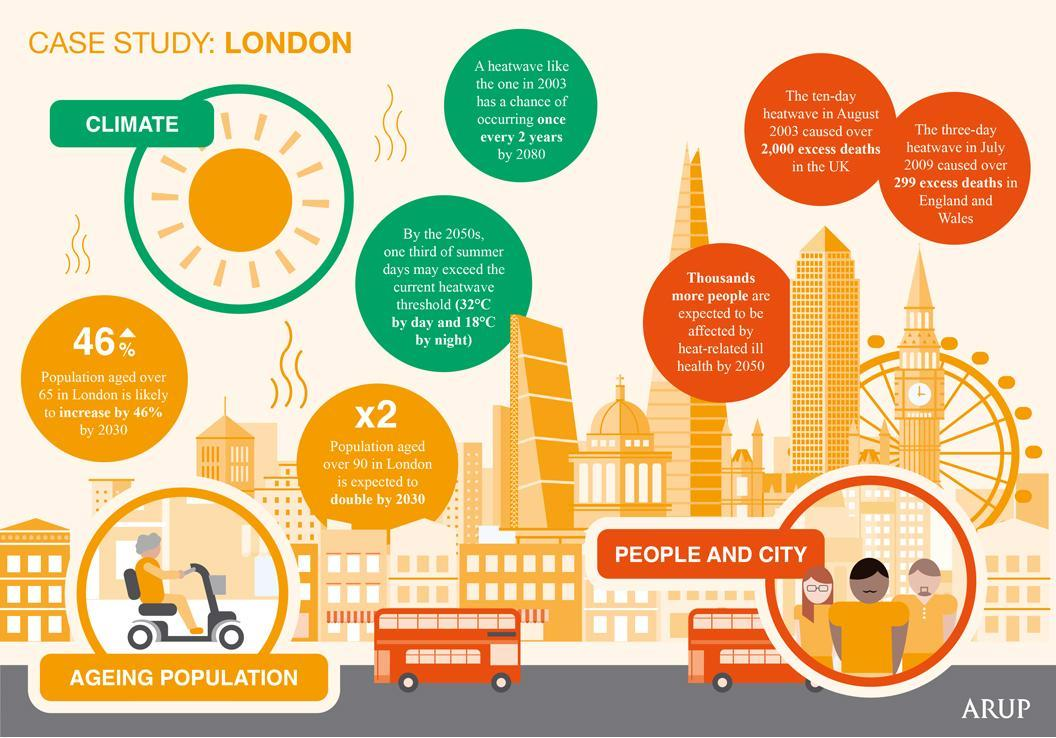How many deaths happened in England because of the heatwave in July 2009?
Answer the question with a short phrase. 299 excess deaths How long the heat wave lasted in UK which caused the death of 2000 people in 2003? ten day How many points have been listed in the infographic regarding "People and City"? 3 What is the color code given to "Ageing Population"- green, red, black, yellow? yellow What is the color code given to climate- blue, green, yellow, pink? green How many points have been listed in the infographic regarding "Climate"? 2 How many points have been listed in the infographic regarding "Ageing Population"? 2 What is the color code given to "People and City"- blue, green, orange, black? orange 